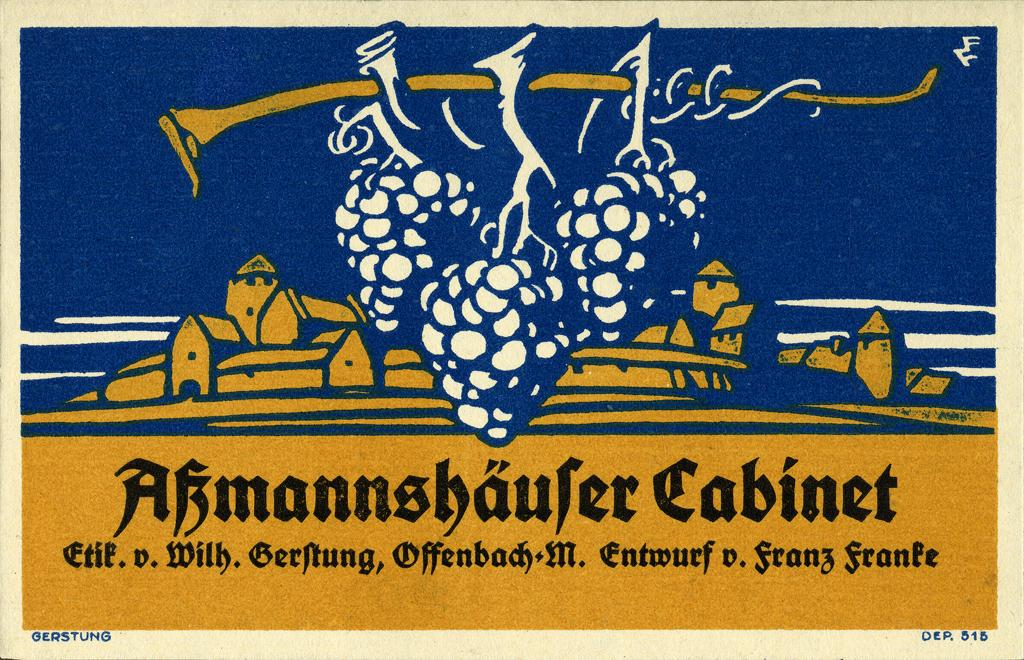<image>
Offer a succinct explanation of the picture presented. A picture of grapes on a yellow and black baskground that says Cabinet. 